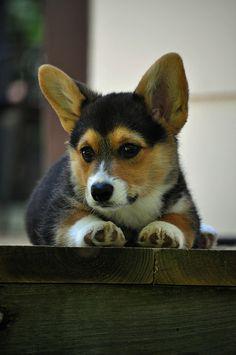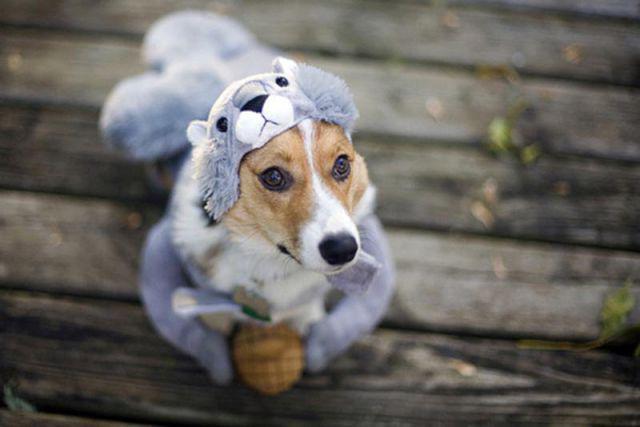The first image is the image on the left, the second image is the image on the right. Assess this claim about the two images: "There are only two dogs and neither of them is wearing a hat.". Correct or not? Answer yes or no. No. The first image is the image on the left, the second image is the image on the right. For the images displayed, is the sentence "At least one dog has it's mouth open." factually correct? Answer yes or no. No. 